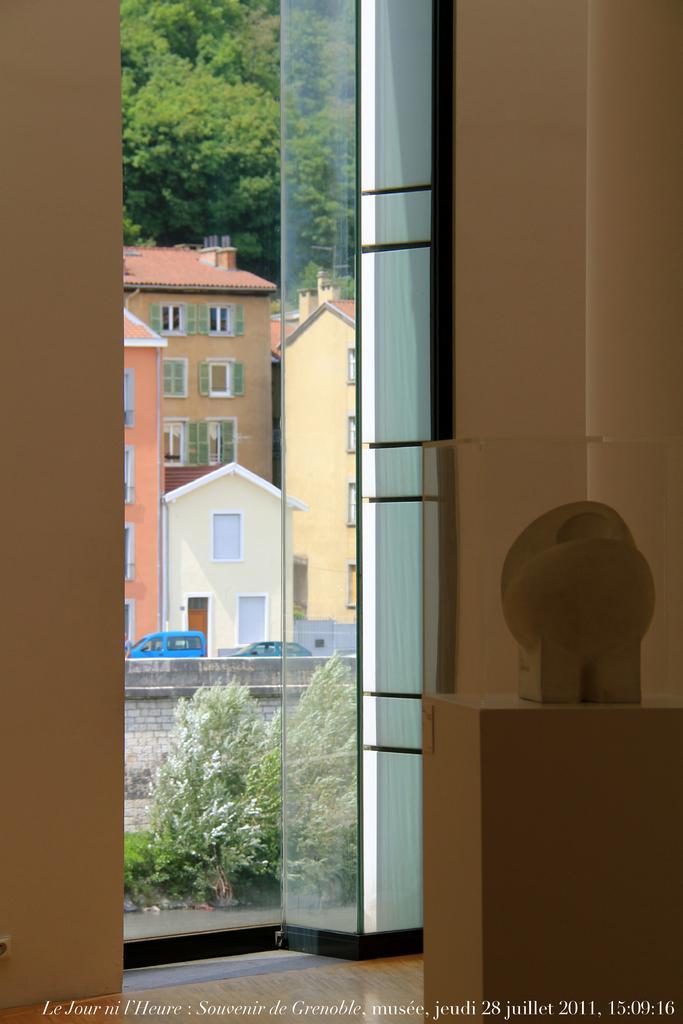In one or two sentences, can you explain what this image depicts? In this image I can see the brown colored walls, a brown colored object on the floor and the door through which I can see few buildings, few trees and few vehicles. 